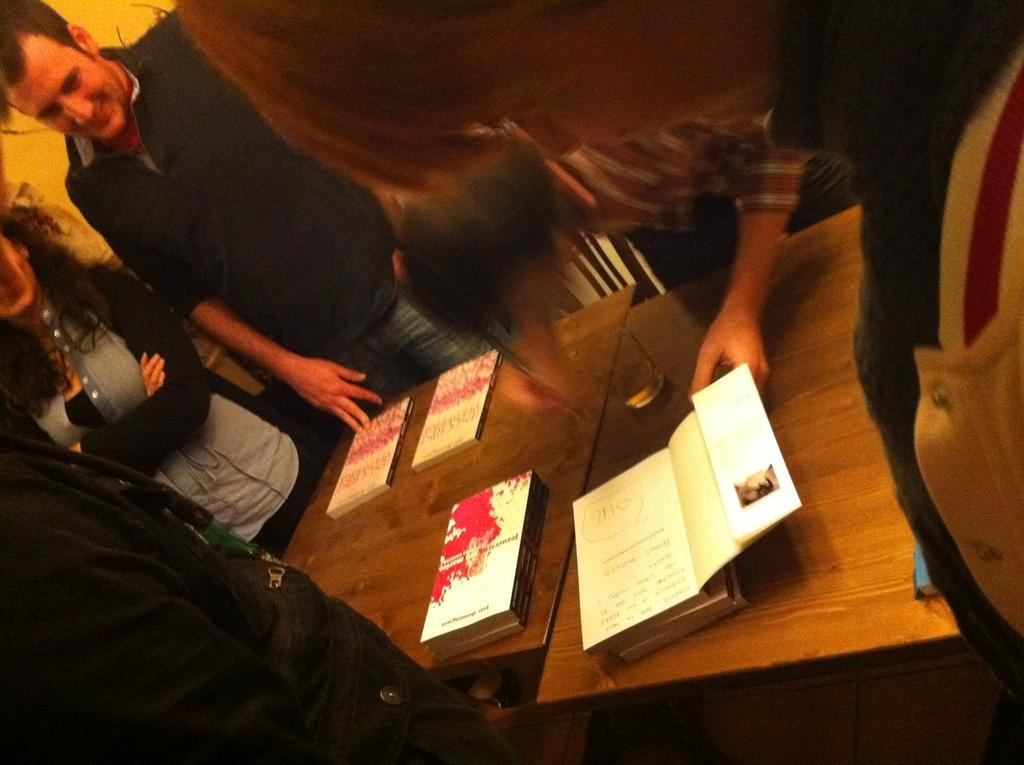How many people are in the image? There are persons standing in the image. What is present in the image besides the people? There is a table in the image. What can be found on the table? The table has books and a glass on it. Can you hear the persons laughing in the image? The image is silent, and there is no indication of laughter or any sound. 